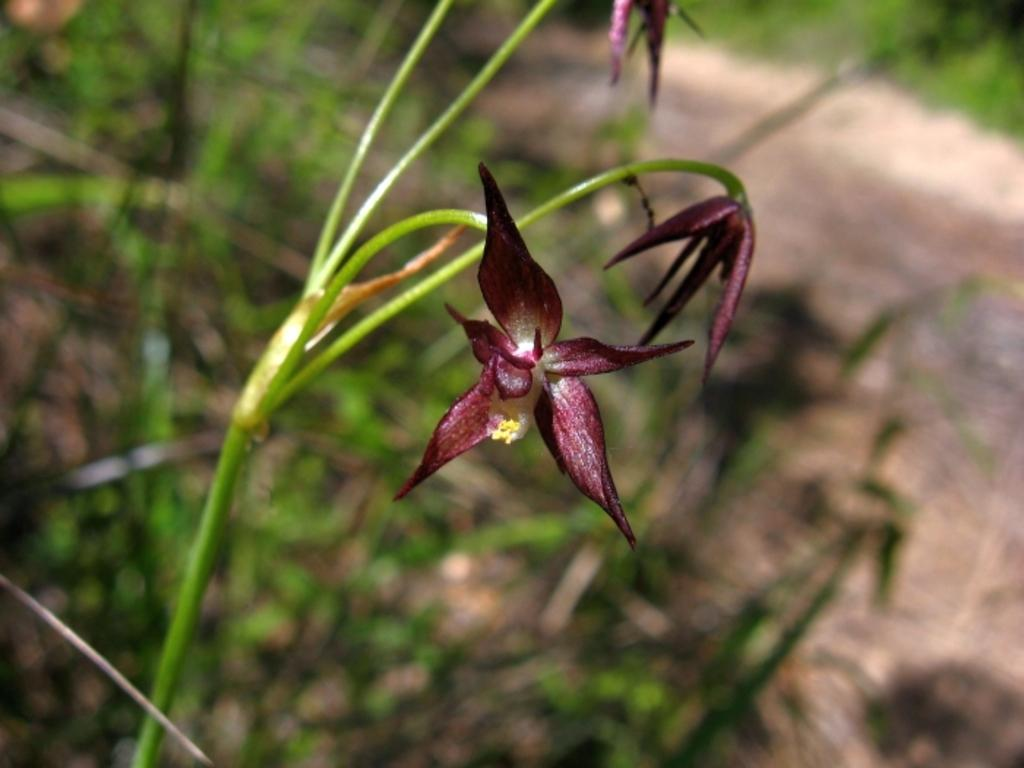What is the main subject in the center of the image? There are flowers in the center of the image. What can be seen in the background of the image? There are plants and the ground visible in the background of the image. Where is the grass located in the image? The grass is in the top right corner of the image. Reasoning: Let' Let's think step by step in order to produce the conversation. We start by identifying the main subject in the image, which is the flowers in the center. Then, we expand the conversation to include other elements in the image, such as the plants, ground, and grass. Each question is designed to elicit a specific detail about the image that is known from the provided facts. Absurd Question/Answer: What type of pollution can be seen affecting the flowers in the image? There is no pollution present in the image; the flowers appear to be healthy and unaffected. What is the tray used for in the image? There is no tray present in the image. What type of burst can be seen in the image? There is no burst present in the image. What is the tray used for in the image? There is no tray present in the image. 